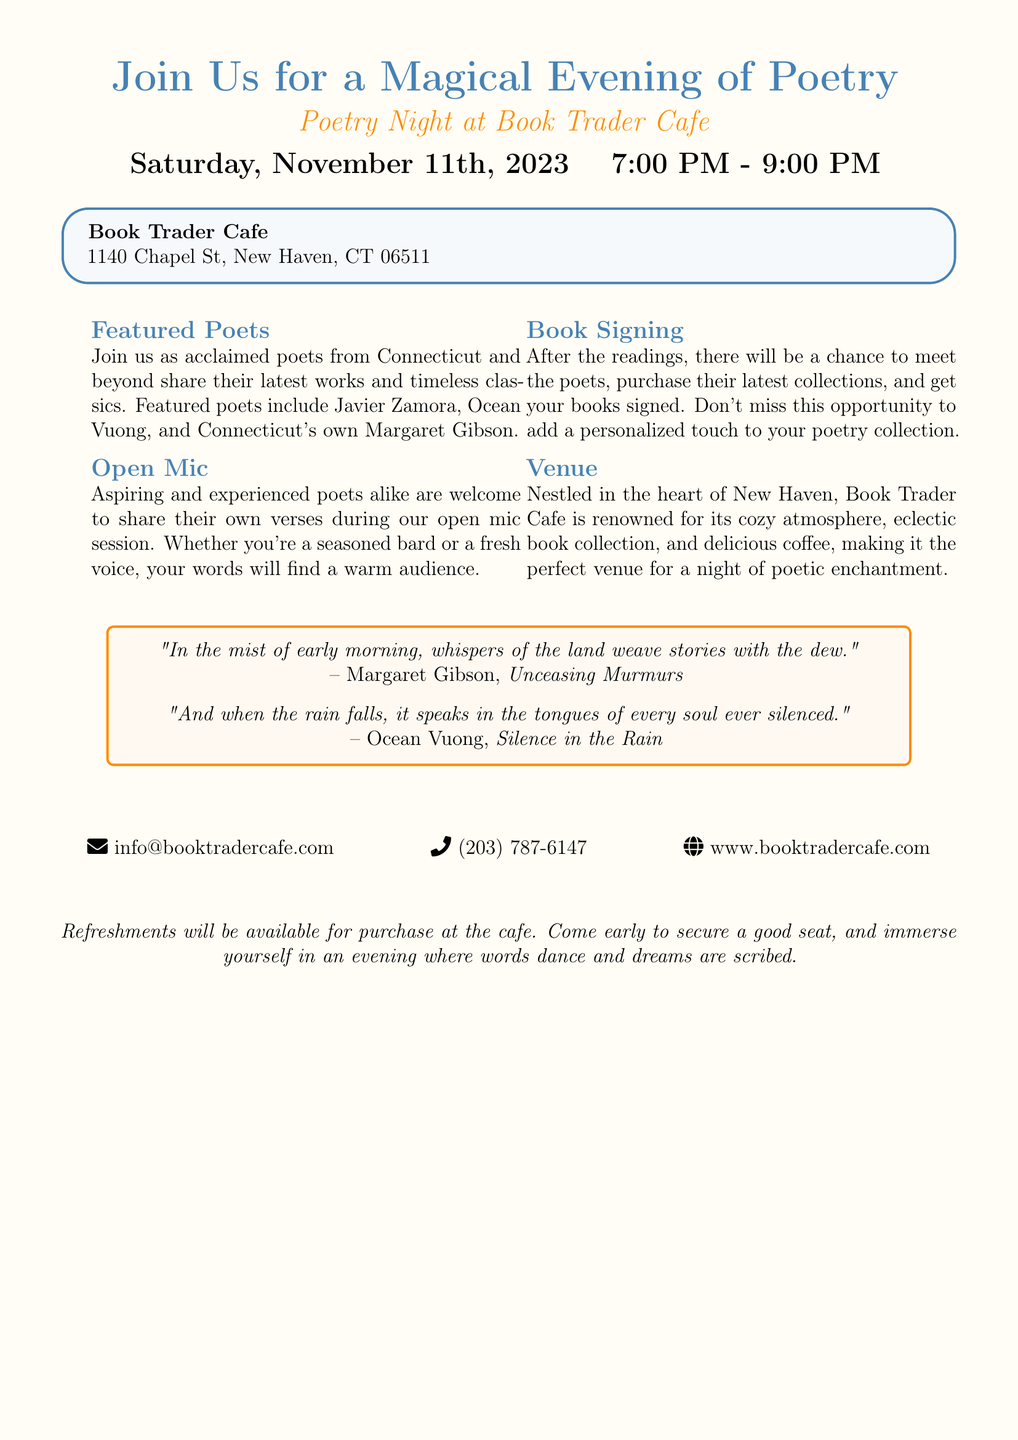What is the date of the poetry reading event? The date is specified in the document as Saturday, November 11th, 2023.
Answer: November 11th, 2023 What time does the event start? The starting time for the event is given as 7:00 PM.
Answer: 7:00 PM Where is the venue located? The document provides the address of the venue as Book Trader Cafe, 1140 Chapel St, New Haven, CT 06511.
Answer: 1140 Chapel St, New Haven, CT 06511 Who are some of the featured poets? The document lists Javier Zamora, Ocean Vuong, and Margaret Gibson as featured poets.
Answer: Javier Zamora, Ocean Vuong, and Margaret Gibson What type of session will be available for aspiring poets? It mentions an open mic session available for poets of all experiences.
Answer: Open mic What will happen after the readings? The document states there will be a chance to meet the poets and get books signed after the readings.
Answer: Book signing What is the nature of the venue described in the advertisement? It is characterized as cozy, with an eclectic book collection and delicious coffee, making it suitable for poetry readings.
Answer: Cozy atmosphere What are attendees encouraged to do before the event starts? Attendees are advised to come early to secure a good seat.
Answer: Come early What are refreshments at the cafe described as? The document mentions that refreshments will be available for purchase at the cafe.
Answer: Available for purchase 